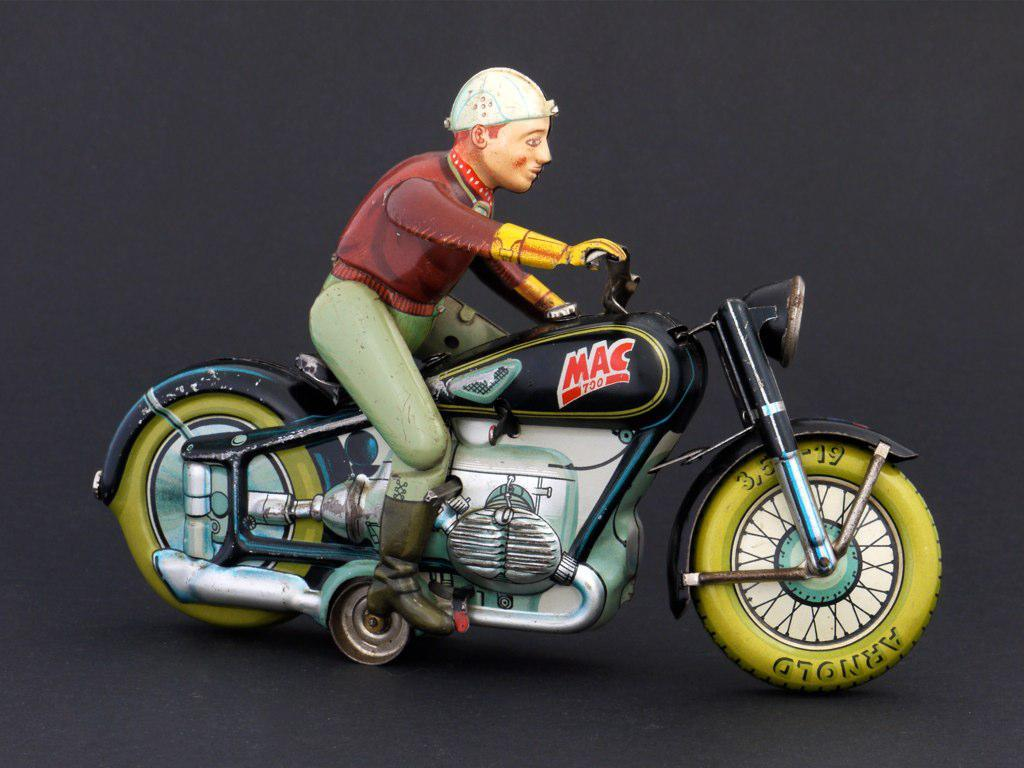What type of toy is in the image? There is a toy bike in the image. Who is on the toy bike? A toy man is sitting on the bike. What is the toy man doing on the bike? The toy man is riding the bike. What color is the toy bike? The bike is black in color. What color are the wheels of the toy bike? The bike has yellow wheels. How many fingers can be seen on the toy man's hand in the image? There are no fingers visible on the toy man's hand in the image, as it is a toy and does not have human-like features. 